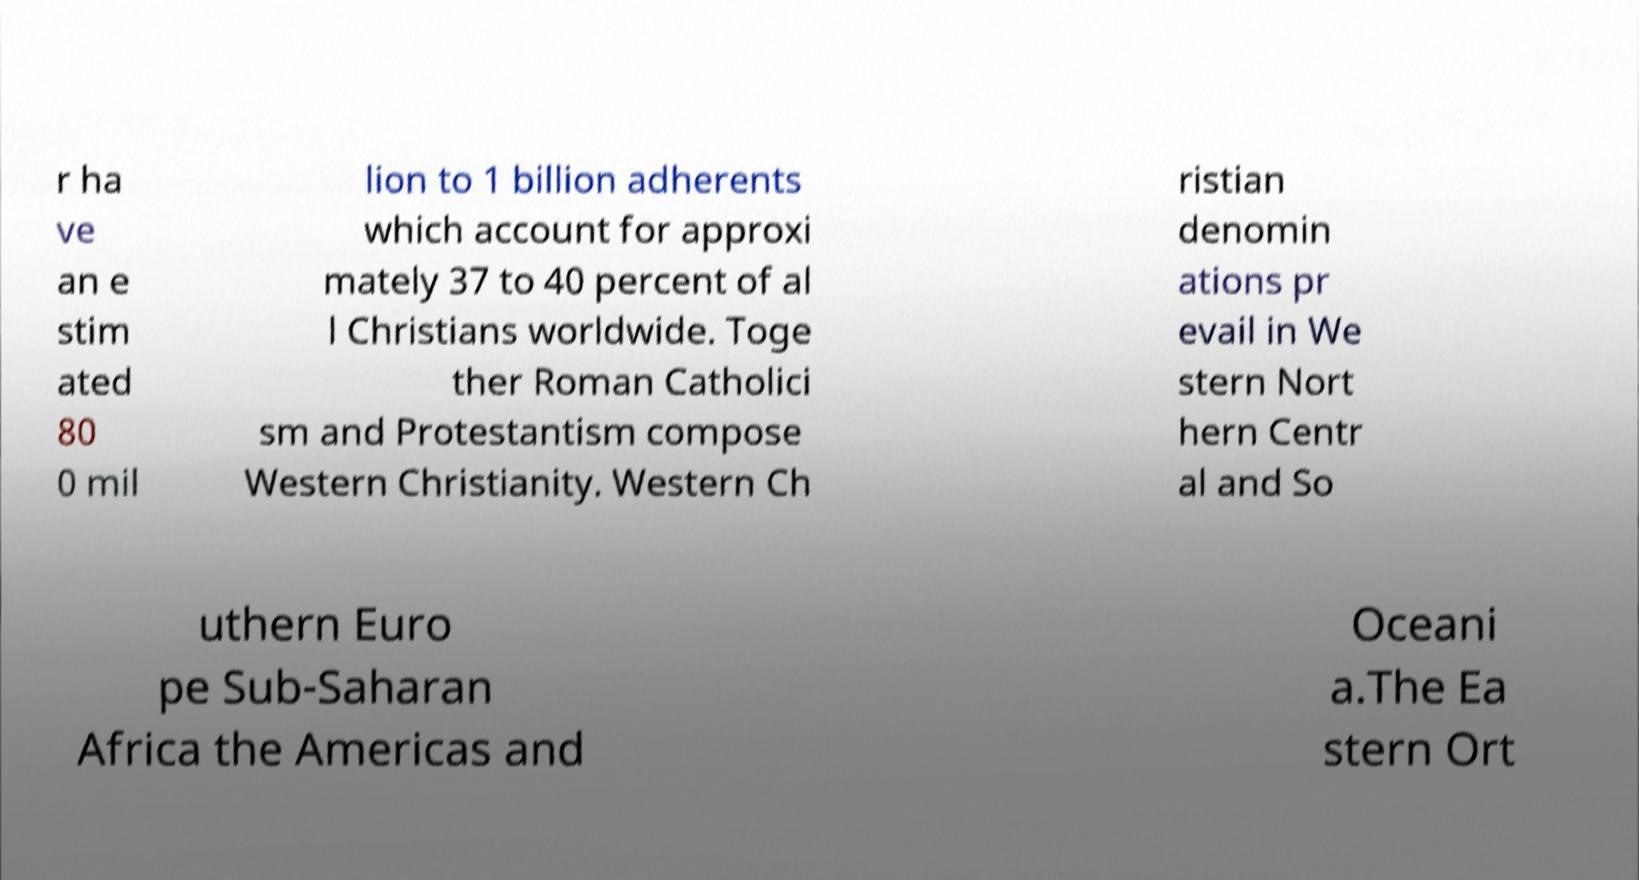Please read and relay the text visible in this image. What does it say? r ha ve an e stim ated 80 0 mil lion to 1 billion adherents which account for approxi mately 37 to 40 percent of al l Christians worldwide. Toge ther Roman Catholici sm and Protestantism compose Western Christianity. Western Ch ristian denomin ations pr evail in We stern Nort hern Centr al and So uthern Euro pe Sub-Saharan Africa the Americas and Oceani a.The Ea stern Ort 